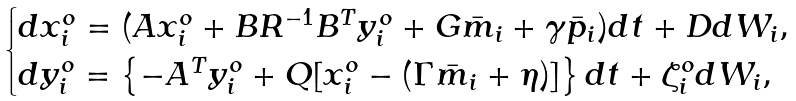<formula> <loc_0><loc_0><loc_500><loc_500>\begin{cases} d x _ { i } ^ { o } = ( A x _ { i } ^ { o } + B R ^ { - 1 } B ^ { T } y _ { i } ^ { o } + G \bar { m } _ { i } + \gamma \bar { p } _ { i } ) d t + D d W _ { i } , \\ d y _ { i } ^ { o } = \left \{ - A ^ { T } y _ { i } ^ { o } + Q [ x _ { i } ^ { o } - ( \Gamma \bar { m } _ { i } + \eta ) ] \right \} d t + \zeta _ { i } ^ { o } d W _ { i } , \end{cases}</formula> 